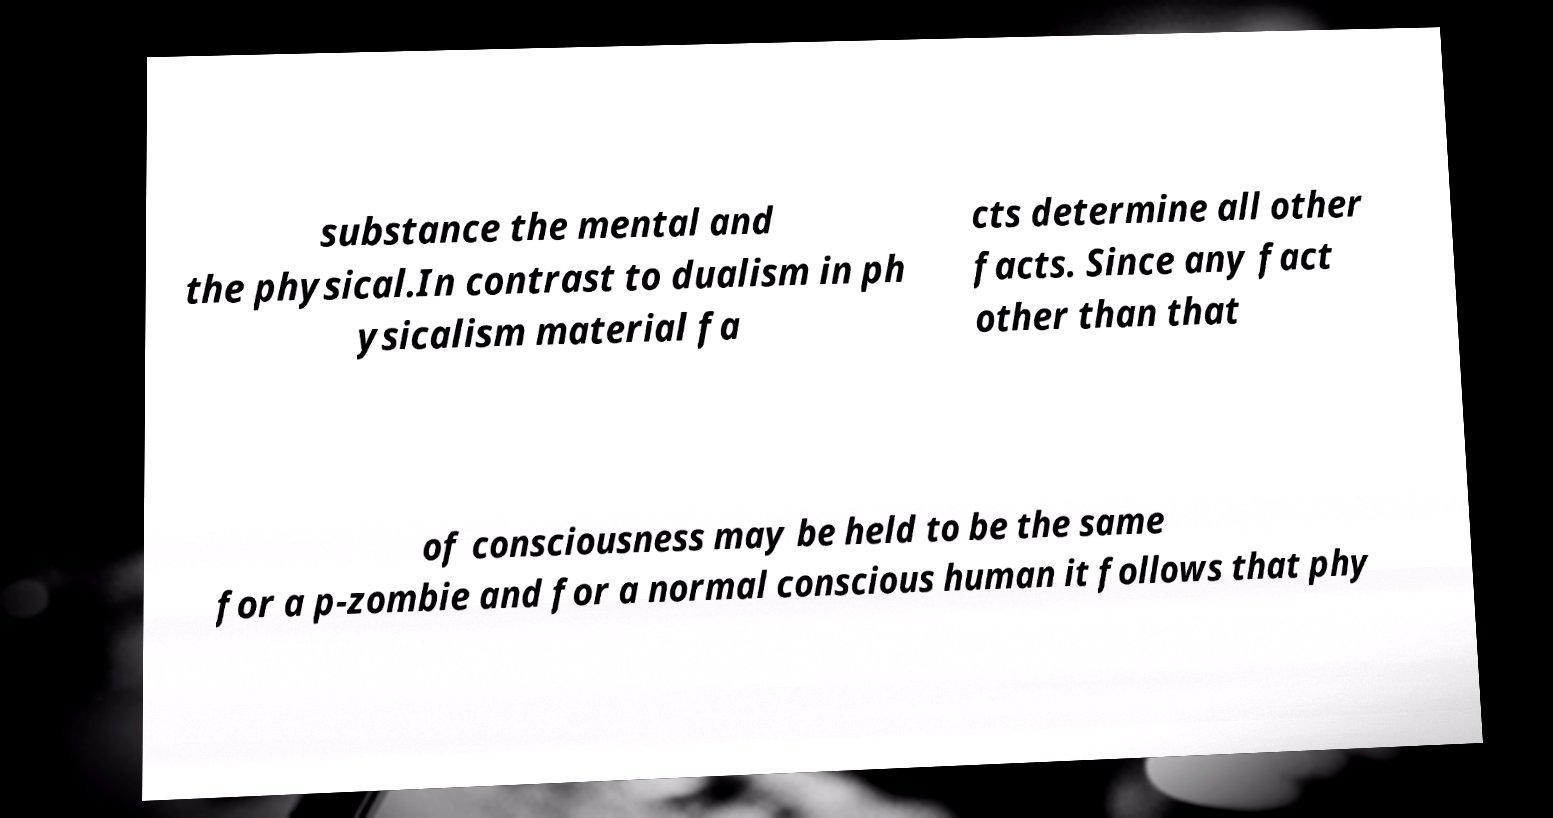I need the written content from this picture converted into text. Can you do that? substance the mental and the physical.In contrast to dualism in ph ysicalism material fa cts determine all other facts. Since any fact other than that of consciousness may be held to be the same for a p-zombie and for a normal conscious human it follows that phy 